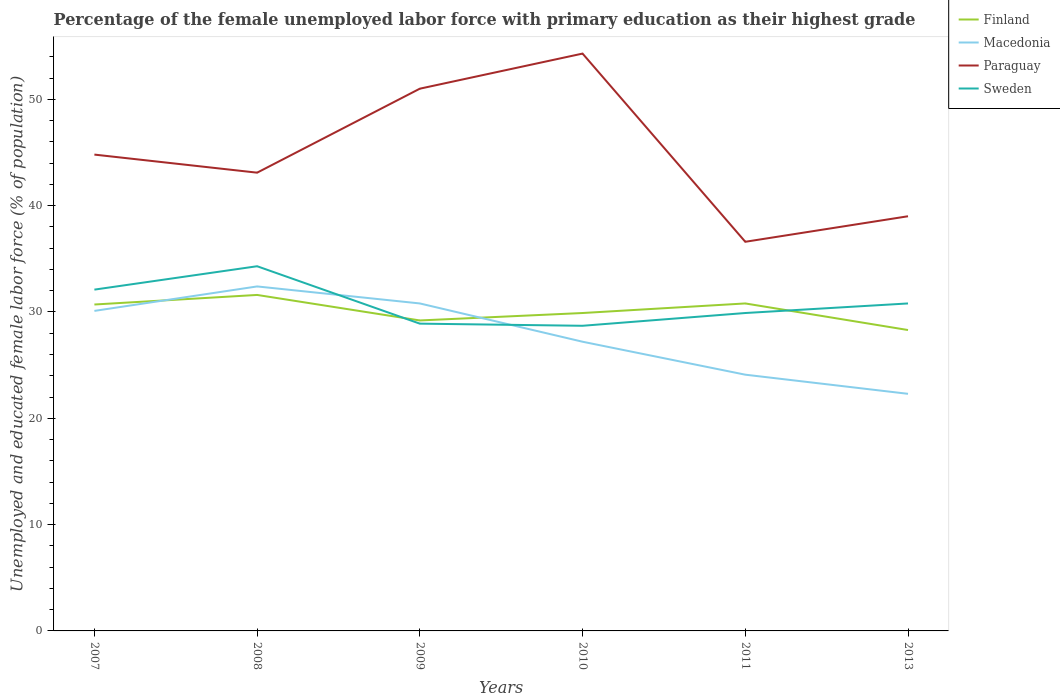How many different coloured lines are there?
Provide a succinct answer. 4. Across all years, what is the maximum percentage of the unemployed female labor force with primary education in Macedonia?
Provide a short and direct response. 22.3. In which year was the percentage of the unemployed female labor force with primary education in Paraguay maximum?
Your response must be concise. 2011. What is the total percentage of the unemployed female labor force with primary education in Finland in the graph?
Your answer should be compact. -1.6. What is the difference between the highest and the second highest percentage of the unemployed female labor force with primary education in Finland?
Provide a succinct answer. 3.3. Is the percentage of the unemployed female labor force with primary education in Finland strictly greater than the percentage of the unemployed female labor force with primary education in Sweden over the years?
Ensure brevity in your answer.  No. How many lines are there?
Offer a terse response. 4. How many years are there in the graph?
Provide a succinct answer. 6. What is the difference between two consecutive major ticks on the Y-axis?
Make the answer very short. 10. Are the values on the major ticks of Y-axis written in scientific E-notation?
Make the answer very short. No. Does the graph contain any zero values?
Give a very brief answer. No. Where does the legend appear in the graph?
Give a very brief answer. Top right. How many legend labels are there?
Provide a succinct answer. 4. How are the legend labels stacked?
Provide a succinct answer. Vertical. What is the title of the graph?
Provide a succinct answer. Percentage of the female unemployed labor force with primary education as their highest grade. What is the label or title of the X-axis?
Your answer should be very brief. Years. What is the label or title of the Y-axis?
Offer a terse response. Unemployed and educated female labor force (% of population). What is the Unemployed and educated female labor force (% of population) in Finland in 2007?
Keep it short and to the point. 30.7. What is the Unemployed and educated female labor force (% of population) of Macedonia in 2007?
Your answer should be very brief. 30.1. What is the Unemployed and educated female labor force (% of population) in Paraguay in 2007?
Give a very brief answer. 44.8. What is the Unemployed and educated female labor force (% of population) of Sweden in 2007?
Your response must be concise. 32.1. What is the Unemployed and educated female labor force (% of population) of Finland in 2008?
Make the answer very short. 31.6. What is the Unemployed and educated female labor force (% of population) in Macedonia in 2008?
Provide a succinct answer. 32.4. What is the Unemployed and educated female labor force (% of population) in Paraguay in 2008?
Ensure brevity in your answer.  43.1. What is the Unemployed and educated female labor force (% of population) of Sweden in 2008?
Offer a very short reply. 34.3. What is the Unemployed and educated female labor force (% of population) in Finland in 2009?
Offer a terse response. 29.2. What is the Unemployed and educated female labor force (% of population) of Macedonia in 2009?
Provide a short and direct response. 30.8. What is the Unemployed and educated female labor force (% of population) in Paraguay in 2009?
Your answer should be compact. 51. What is the Unemployed and educated female labor force (% of population) of Sweden in 2009?
Provide a short and direct response. 28.9. What is the Unemployed and educated female labor force (% of population) of Finland in 2010?
Your answer should be compact. 29.9. What is the Unemployed and educated female labor force (% of population) in Macedonia in 2010?
Your answer should be very brief. 27.2. What is the Unemployed and educated female labor force (% of population) in Paraguay in 2010?
Your answer should be very brief. 54.3. What is the Unemployed and educated female labor force (% of population) of Sweden in 2010?
Give a very brief answer. 28.7. What is the Unemployed and educated female labor force (% of population) of Finland in 2011?
Ensure brevity in your answer.  30.8. What is the Unemployed and educated female labor force (% of population) of Macedonia in 2011?
Your answer should be compact. 24.1. What is the Unemployed and educated female labor force (% of population) of Paraguay in 2011?
Offer a very short reply. 36.6. What is the Unemployed and educated female labor force (% of population) of Sweden in 2011?
Ensure brevity in your answer.  29.9. What is the Unemployed and educated female labor force (% of population) of Finland in 2013?
Offer a very short reply. 28.3. What is the Unemployed and educated female labor force (% of population) of Macedonia in 2013?
Keep it short and to the point. 22.3. What is the Unemployed and educated female labor force (% of population) of Paraguay in 2013?
Keep it short and to the point. 39. What is the Unemployed and educated female labor force (% of population) of Sweden in 2013?
Provide a succinct answer. 30.8. Across all years, what is the maximum Unemployed and educated female labor force (% of population) in Finland?
Make the answer very short. 31.6. Across all years, what is the maximum Unemployed and educated female labor force (% of population) of Macedonia?
Your answer should be compact. 32.4. Across all years, what is the maximum Unemployed and educated female labor force (% of population) of Paraguay?
Provide a short and direct response. 54.3. Across all years, what is the maximum Unemployed and educated female labor force (% of population) in Sweden?
Provide a succinct answer. 34.3. Across all years, what is the minimum Unemployed and educated female labor force (% of population) in Finland?
Give a very brief answer. 28.3. Across all years, what is the minimum Unemployed and educated female labor force (% of population) of Macedonia?
Make the answer very short. 22.3. Across all years, what is the minimum Unemployed and educated female labor force (% of population) of Paraguay?
Provide a succinct answer. 36.6. Across all years, what is the minimum Unemployed and educated female labor force (% of population) of Sweden?
Offer a terse response. 28.7. What is the total Unemployed and educated female labor force (% of population) of Finland in the graph?
Provide a succinct answer. 180.5. What is the total Unemployed and educated female labor force (% of population) in Macedonia in the graph?
Provide a short and direct response. 166.9. What is the total Unemployed and educated female labor force (% of population) in Paraguay in the graph?
Ensure brevity in your answer.  268.8. What is the total Unemployed and educated female labor force (% of population) in Sweden in the graph?
Your answer should be compact. 184.7. What is the difference between the Unemployed and educated female labor force (% of population) of Finland in 2007 and that in 2008?
Keep it short and to the point. -0.9. What is the difference between the Unemployed and educated female labor force (% of population) of Paraguay in 2007 and that in 2008?
Ensure brevity in your answer.  1.7. What is the difference between the Unemployed and educated female labor force (% of population) of Sweden in 2007 and that in 2008?
Give a very brief answer. -2.2. What is the difference between the Unemployed and educated female labor force (% of population) in Macedonia in 2007 and that in 2009?
Offer a very short reply. -0.7. What is the difference between the Unemployed and educated female labor force (% of population) in Paraguay in 2007 and that in 2009?
Make the answer very short. -6.2. What is the difference between the Unemployed and educated female labor force (% of population) of Macedonia in 2007 and that in 2010?
Give a very brief answer. 2.9. What is the difference between the Unemployed and educated female labor force (% of population) in Paraguay in 2007 and that in 2010?
Give a very brief answer. -9.5. What is the difference between the Unemployed and educated female labor force (% of population) in Sweden in 2007 and that in 2010?
Your answer should be very brief. 3.4. What is the difference between the Unemployed and educated female labor force (% of population) in Finland in 2007 and that in 2011?
Provide a short and direct response. -0.1. What is the difference between the Unemployed and educated female labor force (% of population) in Macedonia in 2007 and that in 2011?
Your response must be concise. 6. What is the difference between the Unemployed and educated female labor force (% of population) of Paraguay in 2007 and that in 2011?
Provide a short and direct response. 8.2. What is the difference between the Unemployed and educated female labor force (% of population) in Paraguay in 2007 and that in 2013?
Your answer should be very brief. 5.8. What is the difference between the Unemployed and educated female labor force (% of population) in Sweden in 2007 and that in 2013?
Offer a very short reply. 1.3. What is the difference between the Unemployed and educated female labor force (% of population) of Finland in 2008 and that in 2009?
Provide a short and direct response. 2.4. What is the difference between the Unemployed and educated female labor force (% of population) in Macedonia in 2008 and that in 2009?
Ensure brevity in your answer.  1.6. What is the difference between the Unemployed and educated female labor force (% of population) in Sweden in 2008 and that in 2009?
Provide a succinct answer. 5.4. What is the difference between the Unemployed and educated female labor force (% of population) in Macedonia in 2008 and that in 2010?
Your answer should be very brief. 5.2. What is the difference between the Unemployed and educated female labor force (% of population) of Paraguay in 2008 and that in 2010?
Your answer should be compact. -11.2. What is the difference between the Unemployed and educated female labor force (% of population) in Finland in 2008 and that in 2011?
Your response must be concise. 0.8. What is the difference between the Unemployed and educated female labor force (% of population) in Sweden in 2008 and that in 2011?
Provide a short and direct response. 4.4. What is the difference between the Unemployed and educated female labor force (% of population) of Paraguay in 2009 and that in 2010?
Your answer should be compact. -3.3. What is the difference between the Unemployed and educated female labor force (% of population) in Sweden in 2009 and that in 2010?
Provide a succinct answer. 0.2. What is the difference between the Unemployed and educated female labor force (% of population) in Finland in 2009 and that in 2011?
Provide a succinct answer. -1.6. What is the difference between the Unemployed and educated female labor force (% of population) of Sweden in 2009 and that in 2011?
Make the answer very short. -1. What is the difference between the Unemployed and educated female labor force (% of population) of Finland in 2009 and that in 2013?
Your response must be concise. 0.9. What is the difference between the Unemployed and educated female labor force (% of population) in Paraguay in 2009 and that in 2013?
Provide a succinct answer. 12. What is the difference between the Unemployed and educated female labor force (% of population) in Sweden in 2009 and that in 2013?
Ensure brevity in your answer.  -1.9. What is the difference between the Unemployed and educated female labor force (% of population) of Finland in 2010 and that in 2013?
Give a very brief answer. 1.6. What is the difference between the Unemployed and educated female labor force (% of population) in Macedonia in 2010 and that in 2013?
Make the answer very short. 4.9. What is the difference between the Unemployed and educated female labor force (% of population) of Paraguay in 2010 and that in 2013?
Ensure brevity in your answer.  15.3. What is the difference between the Unemployed and educated female labor force (% of population) in Macedonia in 2011 and that in 2013?
Your answer should be very brief. 1.8. What is the difference between the Unemployed and educated female labor force (% of population) of Finland in 2007 and the Unemployed and educated female labor force (% of population) of Macedonia in 2008?
Your answer should be very brief. -1.7. What is the difference between the Unemployed and educated female labor force (% of population) in Finland in 2007 and the Unemployed and educated female labor force (% of population) in Paraguay in 2008?
Your response must be concise. -12.4. What is the difference between the Unemployed and educated female labor force (% of population) in Macedonia in 2007 and the Unemployed and educated female labor force (% of population) in Paraguay in 2008?
Your answer should be compact. -13. What is the difference between the Unemployed and educated female labor force (% of population) in Paraguay in 2007 and the Unemployed and educated female labor force (% of population) in Sweden in 2008?
Offer a very short reply. 10.5. What is the difference between the Unemployed and educated female labor force (% of population) of Finland in 2007 and the Unemployed and educated female labor force (% of population) of Macedonia in 2009?
Provide a short and direct response. -0.1. What is the difference between the Unemployed and educated female labor force (% of population) of Finland in 2007 and the Unemployed and educated female labor force (% of population) of Paraguay in 2009?
Offer a very short reply. -20.3. What is the difference between the Unemployed and educated female labor force (% of population) in Finland in 2007 and the Unemployed and educated female labor force (% of population) in Sweden in 2009?
Provide a succinct answer. 1.8. What is the difference between the Unemployed and educated female labor force (% of population) in Macedonia in 2007 and the Unemployed and educated female labor force (% of population) in Paraguay in 2009?
Your answer should be very brief. -20.9. What is the difference between the Unemployed and educated female labor force (% of population) in Macedonia in 2007 and the Unemployed and educated female labor force (% of population) in Sweden in 2009?
Make the answer very short. 1.2. What is the difference between the Unemployed and educated female labor force (% of population) of Paraguay in 2007 and the Unemployed and educated female labor force (% of population) of Sweden in 2009?
Your answer should be very brief. 15.9. What is the difference between the Unemployed and educated female labor force (% of population) in Finland in 2007 and the Unemployed and educated female labor force (% of population) in Macedonia in 2010?
Your answer should be compact. 3.5. What is the difference between the Unemployed and educated female labor force (% of population) of Finland in 2007 and the Unemployed and educated female labor force (% of population) of Paraguay in 2010?
Make the answer very short. -23.6. What is the difference between the Unemployed and educated female labor force (% of population) in Macedonia in 2007 and the Unemployed and educated female labor force (% of population) in Paraguay in 2010?
Provide a succinct answer. -24.2. What is the difference between the Unemployed and educated female labor force (% of population) in Macedonia in 2007 and the Unemployed and educated female labor force (% of population) in Sweden in 2010?
Provide a short and direct response. 1.4. What is the difference between the Unemployed and educated female labor force (% of population) of Finland in 2007 and the Unemployed and educated female labor force (% of population) of Sweden in 2011?
Offer a terse response. 0.8. What is the difference between the Unemployed and educated female labor force (% of population) of Macedonia in 2007 and the Unemployed and educated female labor force (% of population) of Sweden in 2011?
Provide a short and direct response. 0.2. What is the difference between the Unemployed and educated female labor force (% of population) of Paraguay in 2007 and the Unemployed and educated female labor force (% of population) of Sweden in 2011?
Provide a succinct answer. 14.9. What is the difference between the Unemployed and educated female labor force (% of population) of Finland in 2007 and the Unemployed and educated female labor force (% of population) of Macedonia in 2013?
Provide a succinct answer. 8.4. What is the difference between the Unemployed and educated female labor force (% of population) of Finland in 2007 and the Unemployed and educated female labor force (% of population) of Sweden in 2013?
Offer a terse response. -0.1. What is the difference between the Unemployed and educated female labor force (% of population) of Finland in 2008 and the Unemployed and educated female labor force (% of population) of Paraguay in 2009?
Your answer should be very brief. -19.4. What is the difference between the Unemployed and educated female labor force (% of population) in Macedonia in 2008 and the Unemployed and educated female labor force (% of population) in Paraguay in 2009?
Your answer should be very brief. -18.6. What is the difference between the Unemployed and educated female labor force (% of population) in Macedonia in 2008 and the Unemployed and educated female labor force (% of population) in Sweden in 2009?
Offer a terse response. 3.5. What is the difference between the Unemployed and educated female labor force (% of population) in Finland in 2008 and the Unemployed and educated female labor force (% of population) in Paraguay in 2010?
Offer a terse response. -22.7. What is the difference between the Unemployed and educated female labor force (% of population) in Finland in 2008 and the Unemployed and educated female labor force (% of population) in Sweden in 2010?
Provide a succinct answer. 2.9. What is the difference between the Unemployed and educated female labor force (% of population) in Macedonia in 2008 and the Unemployed and educated female labor force (% of population) in Paraguay in 2010?
Give a very brief answer. -21.9. What is the difference between the Unemployed and educated female labor force (% of population) of Finland in 2008 and the Unemployed and educated female labor force (% of population) of Macedonia in 2011?
Ensure brevity in your answer.  7.5. What is the difference between the Unemployed and educated female labor force (% of population) in Macedonia in 2008 and the Unemployed and educated female labor force (% of population) in Paraguay in 2011?
Offer a terse response. -4.2. What is the difference between the Unemployed and educated female labor force (% of population) of Macedonia in 2008 and the Unemployed and educated female labor force (% of population) of Sweden in 2011?
Your answer should be very brief. 2.5. What is the difference between the Unemployed and educated female labor force (% of population) of Paraguay in 2008 and the Unemployed and educated female labor force (% of population) of Sweden in 2011?
Offer a terse response. 13.2. What is the difference between the Unemployed and educated female labor force (% of population) of Finland in 2008 and the Unemployed and educated female labor force (% of population) of Macedonia in 2013?
Your response must be concise. 9.3. What is the difference between the Unemployed and educated female labor force (% of population) of Finland in 2008 and the Unemployed and educated female labor force (% of population) of Paraguay in 2013?
Provide a short and direct response. -7.4. What is the difference between the Unemployed and educated female labor force (% of population) of Finland in 2008 and the Unemployed and educated female labor force (% of population) of Sweden in 2013?
Provide a succinct answer. 0.8. What is the difference between the Unemployed and educated female labor force (% of population) of Paraguay in 2008 and the Unemployed and educated female labor force (% of population) of Sweden in 2013?
Provide a succinct answer. 12.3. What is the difference between the Unemployed and educated female labor force (% of population) in Finland in 2009 and the Unemployed and educated female labor force (% of population) in Macedonia in 2010?
Give a very brief answer. 2. What is the difference between the Unemployed and educated female labor force (% of population) in Finland in 2009 and the Unemployed and educated female labor force (% of population) in Paraguay in 2010?
Make the answer very short. -25.1. What is the difference between the Unemployed and educated female labor force (% of population) in Macedonia in 2009 and the Unemployed and educated female labor force (% of population) in Paraguay in 2010?
Offer a very short reply. -23.5. What is the difference between the Unemployed and educated female labor force (% of population) in Paraguay in 2009 and the Unemployed and educated female labor force (% of population) in Sweden in 2010?
Your answer should be compact. 22.3. What is the difference between the Unemployed and educated female labor force (% of population) in Finland in 2009 and the Unemployed and educated female labor force (% of population) in Paraguay in 2011?
Your answer should be very brief. -7.4. What is the difference between the Unemployed and educated female labor force (% of population) of Finland in 2009 and the Unemployed and educated female labor force (% of population) of Sweden in 2011?
Give a very brief answer. -0.7. What is the difference between the Unemployed and educated female labor force (% of population) in Macedonia in 2009 and the Unemployed and educated female labor force (% of population) in Paraguay in 2011?
Your answer should be compact. -5.8. What is the difference between the Unemployed and educated female labor force (% of population) in Macedonia in 2009 and the Unemployed and educated female labor force (% of population) in Sweden in 2011?
Your answer should be very brief. 0.9. What is the difference between the Unemployed and educated female labor force (% of population) in Paraguay in 2009 and the Unemployed and educated female labor force (% of population) in Sweden in 2011?
Provide a succinct answer. 21.1. What is the difference between the Unemployed and educated female labor force (% of population) of Finland in 2009 and the Unemployed and educated female labor force (% of population) of Macedonia in 2013?
Keep it short and to the point. 6.9. What is the difference between the Unemployed and educated female labor force (% of population) in Finland in 2009 and the Unemployed and educated female labor force (% of population) in Sweden in 2013?
Offer a very short reply. -1.6. What is the difference between the Unemployed and educated female labor force (% of population) of Macedonia in 2009 and the Unemployed and educated female labor force (% of population) of Paraguay in 2013?
Give a very brief answer. -8.2. What is the difference between the Unemployed and educated female labor force (% of population) of Paraguay in 2009 and the Unemployed and educated female labor force (% of population) of Sweden in 2013?
Offer a terse response. 20.2. What is the difference between the Unemployed and educated female labor force (% of population) of Finland in 2010 and the Unemployed and educated female labor force (% of population) of Macedonia in 2011?
Offer a terse response. 5.8. What is the difference between the Unemployed and educated female labor force (% of population) in Finland in 2010 and the Unemployed and educated female labor force (% of population) in Paraguay in 2011?
Keep it short and to the point. -6.7. What is the difference between the Unemployed and educated female labor force (% of population) in Finland in 2010 and the Unemployed and educated female labor force (% of population) in Sweden in 2011?
Your answer should be very brief. 0. What is the difference between the Unemployed and educated female labor force (% of population) in Paraguay in 2010 and the Unemployed and educated female labor force (% of population) in Sweden in 2011?
Your answer should be compact. 24.4. What is the difference between the Unemployed and educated female labor force (% of population) in Finland in 2010 and the Unemployed and educated female labor force (% of population) in Paraguay in 2013?
Your answer should be compact. -9.1. What is the difference between the Unemployed and educated female labor force (% of population) in Macedonia in 2010 and the Unemployed and educated female labor force (% of population) in Paraguay in 2013?
Provide a short and direct response. -11.8. What is the difference between the Unemployed and educated female labor force (% of population) of Macedonia in 2010 and the Unemployed and educated female labor force (% of population) of Sweden in 2013?
Offer a very short reply. -3.6. What is the difference between the Unemployed and educated female labor force (% of population) in Paraguay in 2010 and the Unemployed and educated female labor force (% of population) in Sweden in 2013?
Your answer should be very brief. 23.5. What is the difference between the Unemployed and educated female labor force (% of population) of Finland in 2011 and the Unemployed and educated female labor force (% of population) of Paraguay in 2013?
Ensure brevity in your answer.  -8.2. What is the difference between the Unemployed and educated female labor force (% of population) of Macedonia in 2011 and the Unemployed and educated female labor force (% of population) of Paraguay in 2013?
Your response must be concise. -14.9. What is the average Unemployed and educated female labor force (% of population) in Finland per year?
Your answer should be very brief. 30.08. What is the average Unemployed and educated female labor force (% of population) in Macedonia per year?
Provide a succinct answer. 27.82. What is the average Unemployed and educated female labor force (% of population) in Paraguay per year?
Ensure brevity in your answer.  44.8. What is the average Unemployed and educated female labor force (% of population) in Sweden per year?
Your answer should be compact. 30.78. In the year 2007, what is the difference between the Unemployed and educated female labor force (% of population) in Finland and Unemployed and educated female labor force (% of population) in Paraguay?
Ensure brevity in your answer.  -14.1. In the year 2007, what is the difference between the Unemployed and educated female labor force (% of population) of Macedonia and Unemployed and educated female labor force (% of population) of Paraguay?
Your answer should be very brief. -14.7. In the year 2007, what is the difference between the Unemployed and educated female labor force (% of population) in Macedonia and Unemployed and educated female labor force (% of population) in Sweden?
Give a very brief answer. -2. In the year 2008, what is the difference between the Unemployed and educated female labor force (% of population) of Finland and Unemployed and educated female labor force (% of population) of Macedonia?
Your answer should be compact. -0.8. In the year 2008, what is the difference between the Unemployed and educated female labor force (% of population) of Finland and Unemployed and educated female labor force (% of population) of Paraguay?
Offer a terse response. -11.5. In the year 2008, what is the difference between the Unemployed and educated female labor force (% of population) of Macedonia and Unemployed and educated female labor force (% of population) of Paraguay?
Your response must be concise. -10.7. In the year 2008, what is the difference between the Unemployed and educated female labor force (% of population) of Macedonia and Unemployed and educated female labor force (% of population) of Sweden?
Keep it short and to the point. -1.9. In the year 2009, what is the difference between the Unemployed and educated female labor force (% of population) of Finland and Unemployed and educated female labor force (% of population) of Paraguay?
Give a very brief answer. -21.8. In the year 2009, what is the difference between the Unemployed and educated female labor force (% of population) of Finland and Unemployed and educated female labor force (% of population) of Sweden?
Offer a very short reply. 0.3. In the year 2009, what is the difference between the Unemployed and educated female labor force (% of population) in Macedonia and Unemployed and educated female labor force (% of population) in Paraguay?
Ensure brevity in your answer.  -20.2. In the year 2009, what is the difference between the Unemployed and educated female labor force (% of population) of Macedonia and Unemployed and educated female labor force (% of population) of Sweden?
Your answer should be compact. 1.9. In the year 2009, what is the difference between the Unemployed and educated female labor force (% of population) of Paraguay and Unemployed and educated female labor force (% of population) of Sweden?
Your answer should be very brief. 22.1. In the year 2010, what is the difference between the Unemployed and educated female labor force (% of population) in Finland and Unemployed and educated female labor force (% of population) in Paraguay?
Your answer should be very brief. -24.4. In the year 2010, what is the difference between the Unemployed and educated female labor force (% of population) in Finland and Unemployed and educated female labor force (% of population) in Sweden?
Offer a terse response. 1.2. In the year 2010, what is the difference between the Unemployed and educated female labor force (% of population) in Macedonia and Unemployed and educated female labor force (% of population) in Paraguay?
Your response must be concise. -27.1. In the year 2010, what is the difference between the Unemployed and educated female labor force (% of population) of Macedonia and Unemployed and educated female labor force (% of population) of Sweden?
Your answer should be compact. -1.5. In the year 2010, what is the difference between the Unemployed and educated female labor force (% of population) in Paraguay and Unemployed and educated female labor force (% of population) in Sweden?
Your answer should be very brief. 25.6. In the year 2011, what is the difference between the Unemployed and educated female labor force (% of population) in Finland and Unemployed and educated female labor force (% of population) in Macedonia?
Your response must be concise. 6.7. In the year 2011, what is the difference between the Unemployed and educated female labor force (% of population) of Macedonia and Unemployed and educated female labor force (% of population) of Sweden?
Offer a terse response. -5.8. In the year 2011, what is the difference between the Unemployed and educated female labor force (% of population) in Paraguay and Unemployed and educated female labor force (% of population) in Sweden?
Your answer should be very brief. 6.7. In the year 2013, what is the difference between the Unemployed and educated female labor force (% of population) of Finland and Unemployed and educated female labor force (% of population) of Macedonia?
Your answer should be very brief. 6. In the year 2013, what is the difference between the Unemployed and educated female labor force (% of population) in Macedonia and Unemployed and educated female labor force (% of population) in Paraguay?
Offer a very short reply. -16.7. In the year 2013, what is the difference between the Unemployed and educated female labor force (% of population) in Paraguay and Unemployed and educated female labor force (% of population) in Sweden?
Your response must be concise. 8.2. What is the ratio of the Unemployed and educated female labor force (% of population) in Finland in 2007 to that in 2008?
Offer a terse response. 0.97. What is the ratio of the Unemployed and educated female labor force (% of population) of Macedonia in 2007 to that in 2008?
Your answer should be compact. 0.93. What is the ratio of the Unemployed and educated female labor force (% of population) in Paraguay in 2007 to that in 2008?
Your answer should be compact. 1.04. What is the ratio of the Unemployed and educated female labor force (% of population) of Sweden in 2007 to that in 2008?
Offer a terse response. 0.94. What is the ratio of the Unemployed and educated female labor force (% of population) of Finland in 2007 to that in 2009?
Offer a very short reply. 1.05. What is the ratio of the Unemployed and educated female labor force (% of population) of Macedonia in 2007 to that in 2009?
Your answer should be compact. 0.98. What is the ratio of the Unemployed and educated female labor force (% of population) of Paraguay in 2007 to that in 2009?
Your answer should be compact. 0.88. What is the ratio of the Unemployed and educated female labor force (% of population) of Sweden in 2007 to that in 2009?
Your answer should be compact. 1.11. What is the ratio of the Unemployed and educated female labor force (% of population) of Finland in 2007 to that in 2010?
Keep it short and to the point. 1.03. What is the ratio of the Unemployed and educated female labor force (% of population) in Macedonia in 2007 to that in 2010?
Provide a short and direct response. 1.11. What is the ratio of the Unemployed and educated female labor force (% of population) of Paraguay in 2007 to that in 2010?
Offer a very short reply. 0.82. What is the ratio of the Unemployed and educated female labor force (% of population) in Sweden in 2007 to that in 2010?
Your answer should be very brief. 1.12. What is the ratio of the Unemployed and educated female labor force (% of population) of Macedonia in 2007 to that in 2011?
Ensure brevity in your answer.  1.25. What is the ratio of the Unemployed and educated female labor force (% of population) of Paraguay in 2007 to that in 2011?
Give a very brief answer. 1.22. What is the ratio of the Unemployed and educated female labor force (% of population) in Sweden in 2007 to that in 2011?
Offer a terse response. 1.07. What is the ratio of the Unemployed and educated female labor force (% of population) of Finland in 2007 to that in 2013?
Give a very brief answer. 1.08. What is the ratio of the Unemployed and educated female labor force (% of population) of Macedonia in 2007 to that in 2013?
Make the answer very short. 1.35. What is the ratio of the Unemployed and educated female labor force (% of population) in Paraguay in 2007 to that in 2013?
Give a very brief answer. 1.15. What is the ratio of the Unemployed and educated female labor force (% of population) of Sweden in 2007 to that in 2013?
Give a very brief answer. 1.04. What is the ratio of the Unemployed and educated female labor force (% of population) of Finland in 2008 to that in 2009?
Your answer should be very brief. 1.08. What is the ratio of the Unemployed and educated female labor force (% of population) of Macedonia in 2008 to that in 2009?
Offer a very short reply. 1.05. What is the ratio of the Unemployed and educated female labor force (% of population) of Paraguay in 2008 to that in 2009?
Offer a very short reply. 0.85. What is the ratio of the Unemployed and educated female labor force (% of population) of Sweden in 2008 to that in 2009?
Your response must be concise. 1.19. What is the ratio of the Unemployed and educated female labor force (% of population) in Finland in 2008 to that in 2010?
Offer a very short reply. 1.06. What is the ratio of the Unemployed and educated female labor force (% of population) of Macedonia in 2008 to that in 2010?
Give a very brief answer. 1.19. What is the ratio of the Unemployed and educated female labor force (% of population) of Paraguay in 2008 to that in 2010?
Provide a succinct answer. 0.79. What is the ratio of the Unemployed and educated female labor force (% of population) in Sweden in 2008 to that in 2010?
Give a very brief answer. 1.2. What is the ratio of the Unemployed and educated female labor force (% of population) of Finland in 2008 to that in 2011?
Your response must be concise. 1.03. What is the ratio of the Unemployed and educated female labor force (% of population) in Macedonia in 2008 to that in 2011?
Ensure brevity in your answer.  1.34. What is the ratio of the Unemployed and educated female labor force (% of population) of Paraguay in 2008 to that in 2011?
Keep it short and to the point. 1.18. What is the ratio of the Unemployed and educated female labor force (% of population) in Sweden in 2008 to that in 2011?
Make the answer very short. 1.15. What is the ratio of the Unemployed and educated female labor force (% of population) of Finland in 2008 to that in 2013?
Keep it short and to the point. 1.12. What is the ratio of the Unemployed and educated female labor force (% of population) in Macedonia in 2008 to that in 2013?
Provide a succinct answer. 1.45. What is the ratio of the Unemployed and educated female labor force (% of population) in Paraguay in 2008 to that in 2013?
Your answer should be very brief. 1.11. What is the ratio of the Unemployed and educated female labor force (% of population) of Sweden in 2008 to that in 2013?
Offer a very short reply. 1.11. What is the ratio of the Unemployed and educated female labor force (% of population) in Finland in 2009 to that in 2010?
Your response must be concise. 0.98. What is the ratio of the Unemployed and educated female labor force (% of population) in Macedonia in 2009 to that in 2010?
Your answer should be compact. 1.13. What is the ratio of the Unemployed and educated female labor force (% of population) in Paraguay in 2009 to that in 2010?
Provide a succinct answer. 0.94. What is the ratio of the Unemployed and educated female labor force (% of population) in Sweden in 2009 to that in 2010?
Your response must be concise. 1.01. What is the ratio of the Unemployed and educated female labor force (% of population) of Finland in 2009 to that in 2011?
Ensure brevity in your answer.  0.95. What is the ratio of the Unemployed and educated female labor force (% of population) in Macedonia in 2009 to that in 2011?
Your response must be concise. 1.28. What is the ratio of the Unemployed and educated female labor force (% of population) of Paraguay in 2009 to that in 2011?
Provide a succinct answer. 1.39. What is the ratio of the Unemployed and educated female labor force (% of population) of Sweden in 2009 to that in 2011?
Offer a very short reply. 0.97. What is the ratio of the Unemployed and educated female labor force (% of population) in Finland in 2009 to that in 2013?
Make the answer very short. 1.03. What is the ratio of the Unemployed and educated female labor force (% of population) in Macedonia in 2009 to that in 2013?
Provide a short and direct response. 1.38. What is the ratio of the Unemployed and educated female labor force (% of population) of Paraguay in 2009 to that in 2013?
Keep it short and to the point. 1.31. What is the ratio of the Unemployed and educated female labor force (% of population) in Sweden in 2009 to that in 2013?
Make the answer very short. 0.94. What is the ratio of the Unemployed and educated female labor force (% of population) in Finland in 2010 to that in 2011?
Offer a terse response. 0.97. What is the ratio of the Unemployed and educated female labor force (% of population) in Macedonia in 2010 to that in 2011?
Give a very brief answer. 1.13. What is the ratio of the Unemployed and educated female labor force (% of population) in Paraguay in 2010 to that in 2011?
Your response must be concise. 1.48. What is the ratio of the Unemployed and educated female labor force (% of population) of Sweden in 2010 to that in 2011?
Give a very brief answer. 0.96. What is the ratio of the Unemployed and educated female labor force (% of population) in Finland in 2010 to that in 2013?
Give a very brief answer. 1.06. What is the ratio of the Unemployed and educated female labor force (% of population) of Macedonia in 2010 to that in 2013?
Your answer should be very brief. 1.22. What is the ratio of the Unemployed and educated female labor force (% of population) in Paraguay in 2010 to that in 2013?
Offer a very short reply. 1.39. What is the ratio of the Unemployed and educated female labor force (% of population) of Sweden in 2010 to that in 2013?
Provide a succinct answer. 0.93. What is the ratio of the Unemployed and educated female labor force (% of population) in Finland in 2011 to that in 2013?
Your answer should be compact. 1.09. What is the ratio of the Unemployed and educated female labor force (% of population) in Macedonia in 2011 to that in 2013?
Your answer should be compact. 1.08. What is the ratio of the Unemployed and educated female labor force (% of population) in Paraguay in 2011 to that in 2013?
Keep it short and to the point. 0.94. What is the ratio of the Unemployed and educated female labor force (% of population) in Sweden in 2011 to that in 2013?
Ensure brevity in your answer.  0.97. What is the difference between the highest and the second highest Unemployed and educated female labor force (% of population) of Macedonia?
Offer a very short reply. 1.6. What is the difference between the highest and the second highest Unemployed and educated female labor force (% of population) of Sweden?
Make the answer very short. 2.2. What is the difference between the highest and the lowest Unemployed and educated female labor force (% of population) of Paraguay?
Keep it short and to the point. 17.7. 